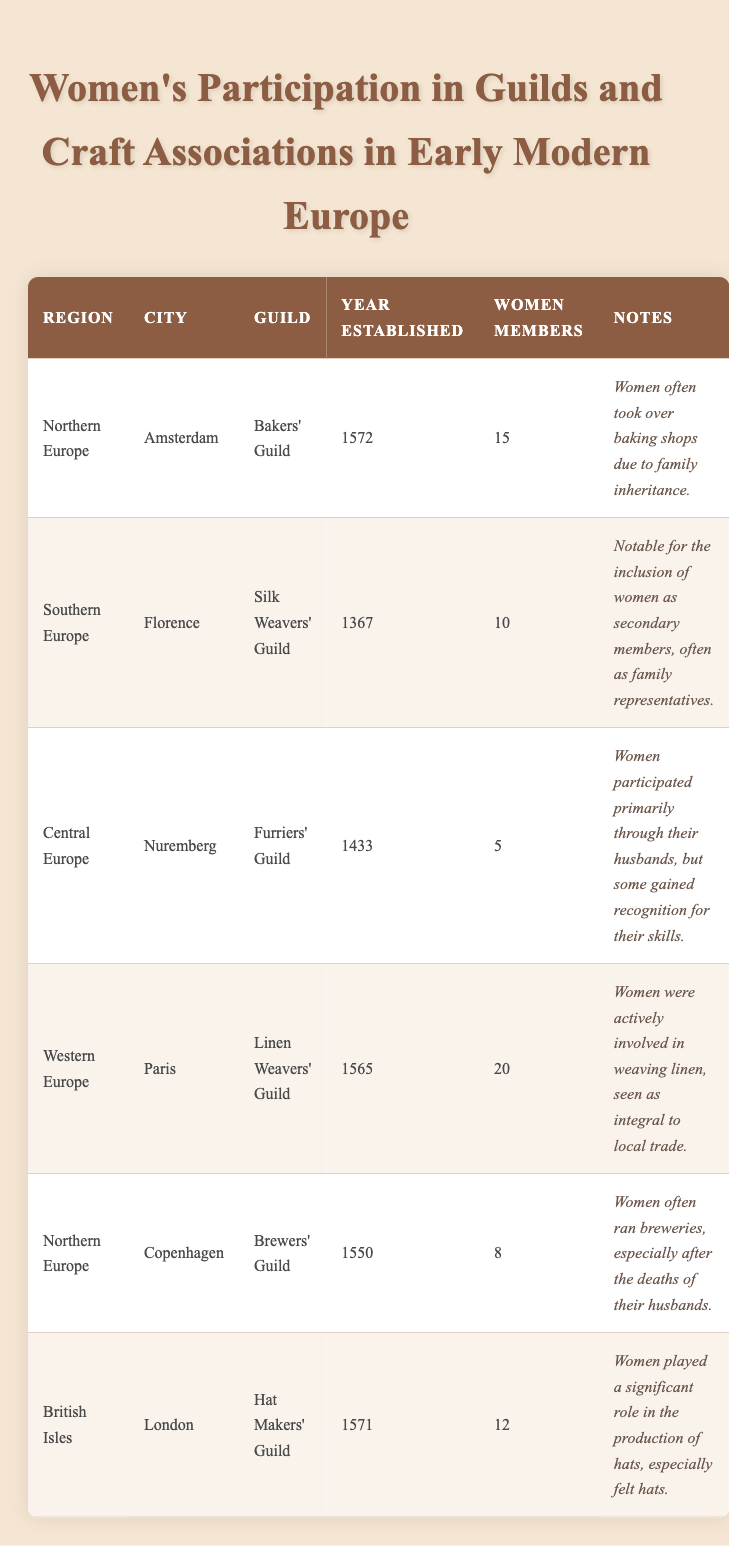What city has the highest number of women members in a guild? Looking through the table, I notice that Paris has 20 women members in the Linen Weavers' Guild, which is more than any other city listed.
Answer: Paris How many women were members of the Bakers' Guild in Amsterdam? The table directly states that there were 15 women members in the Bakers' Guild located in Amsterdam.
Answer: 15 What is the total number of women members across all guilds listed? Adding the number of women members from each city: 15 (Amsterdam) + 10 (Florence) + 5 (Nuremberg) + 20 (Paris) + 8 (Copenhagen) + 12 (London) gives a total of 70 women members.
Answer: 70 Did more women participate in the Furriers' Guild in Nuremberg than the Silk Weavers' Guild in Florence? The Furriers' Guild in Nuremberg had 5 women members, whereas the Silk Weavers' Guild in Florence had 10 women members, indicating that fewer women participated in the Furriers' Guild.
Answer: No Which region had the earliest established guild among those listed? The Silk Weavers' Guild in Florence was established in 1367, which is earlier than any of the other guilds listed. The Bakers' Guild in Amsterdam, for example, was established in 1572.
Answer: Southern Europe What proportion of women members in the Linen Weavers' Guild in Paris compared to the total women members of the guilds listed? The total number of women members from all guilds is 70, and the Linen Weavers' Guild in Paris had 20 women members. The proportion is calculated as 20/70 = 0.286, or approximately 28.6%.
Answer: Approximately 28.6% Are there any guilds listed that have members exclusively made up of women? None of the entries in the table indicate that any guild is exclusively composed of women; they mostly participate through family connections or representational roles.
Answer: No How many guilds are referenced in the data? The table presents information about six guilds in total, as indicated by the number of rows in the data.
Answer: 6 What role did women typically have in the Furriers' Guild in Nuremberg? The notes indicate that women participated in the Furriers' Guild primarily through their husbands, suggesting a secondary or supportive role in membership.
Answer: Secondary role 